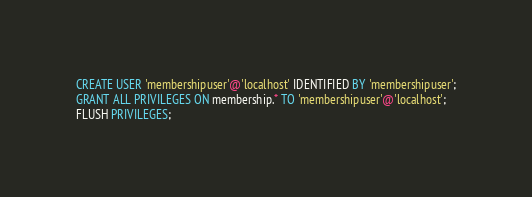<code> <loc_0><loc_0><loc_500><loc_500><_SQL_>CREATE USER 'membershipuser'@'localhost' IDENTIFIED BY 'membershipuser';
GRANT ALL PRIVILEGES ON membership.* TO 'membershipuser'@'localhost';
FLUSH PRIVILEGES;

</code> 